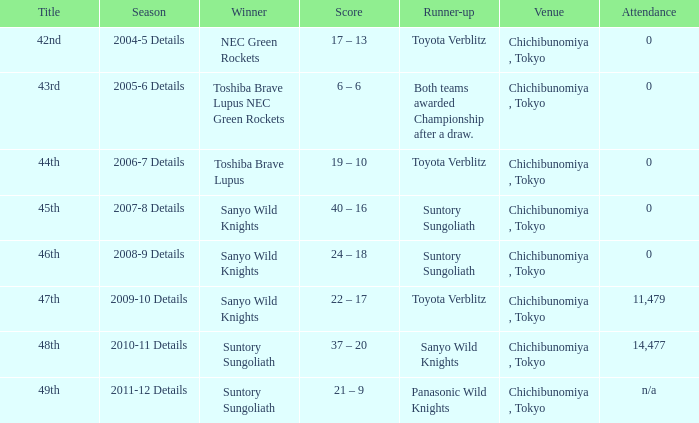What is the score when the victor was suntory sungoliath, and the attendance number was not available? 21 – 9. 